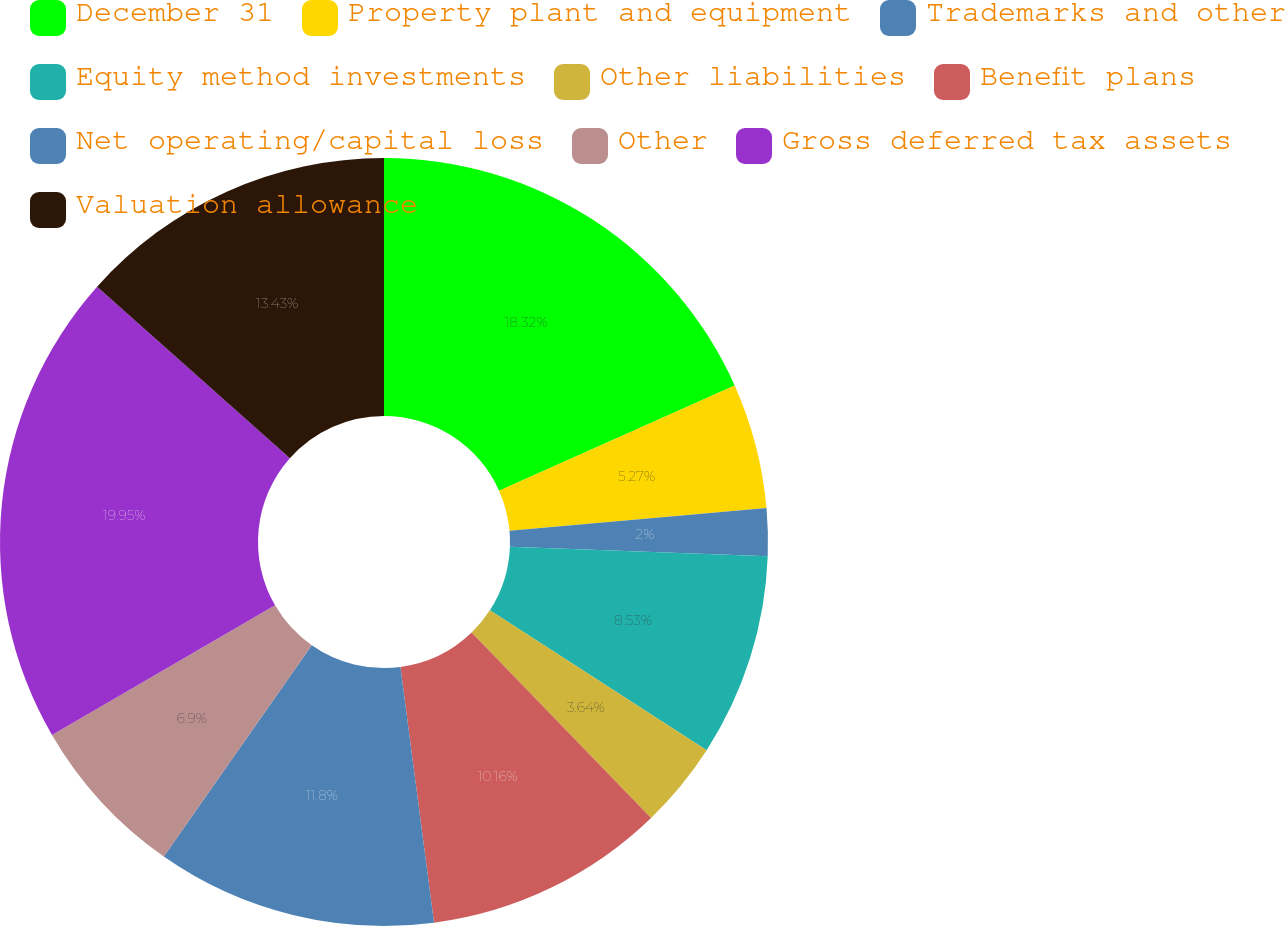Convert chart to OTSL. <chart><loc_0><loc_0><loc_500><loc_500><pie_chart><fcel>December 31<fcel>Property plant and equipment<fcel>Trademarks and other<fcel>Equity method investments<fcel>Other liabilities<fcel>Benefit plans<fcel>Net operating/capital loss<fcel>Other<fcel>Gross deferred tax assets<fcel>Valuation allowance<nl><fcel>18.32%<fcel>5.27%<fcel>2.0%<fcel>8.53%<fcel>3.64%<fcel>10.16%<fcel>11.8%<fcel>6.9%<fcel>19.95%<fcel>13.43%<nl></chart> 